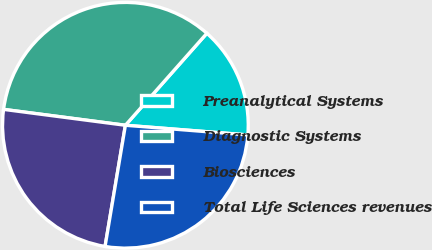Convert chart. <chart><loc_0><loc_0><loc_500><loc_500><pie_chart><fcel>Preanalytical Systems<fcel>Diagnostic Systems<fcel>Biosciences<fcel>Total Life Sciences revenues<nl><fcel>14.72%<fcel>34.47%<fcel>24.42%<fcel>26.39%<nl></chart> 